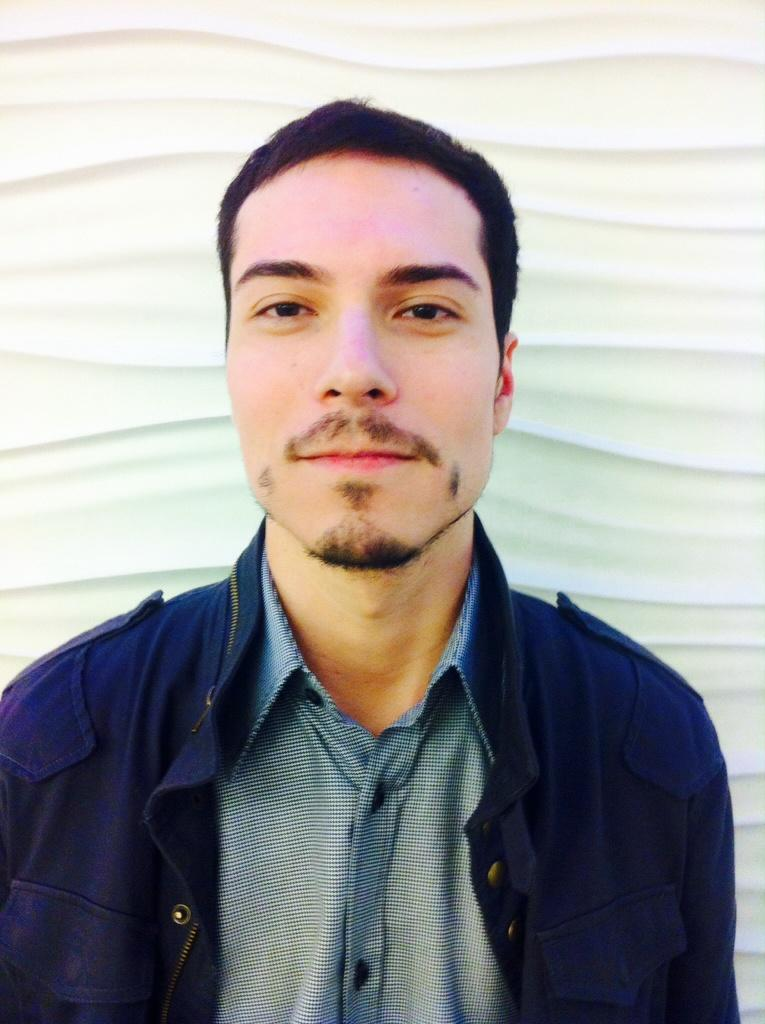Who or what is present in the image? There is a person in the image. What is the person wearing? The person is wearing a blue jacket. What can be seen in the background of the image? There is a wall in the background of the image. What scientific experiment is the person conducting in the image? There is no indication of a scientific experiment in the image; it simply shows a person wearing a blue jacket with a wall in the background. 